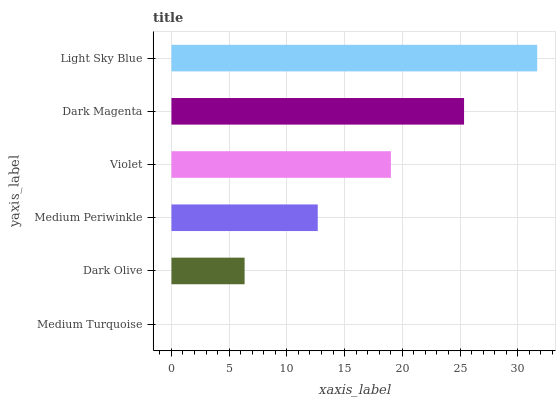Is Medium Turquoise the minimum?
Answer yes or no. Yes. Is Light Sky Blue the maximum?
Answer yes or no. Yes. Is Dark Olive the minimum?
Answer yes or no. No. Is Dark Olive the maximum?
Answer yes or no. No. Is Dark Olive greater than Medium Turquoise?
Answer yes or no. Yes. Is Medium Turquoise less than Dark Olive?
Answer yes or no. Yes. Is Medium Turquoise greater than Dark Olive?
Answer yes or no. No. Is Dark Olive less than Medium Turquoise?
Answer yes or no. No. Is Violet the high median?
Answer yes or no. Yes. Is Medium Periwinkle the low median?
Answer yes or no. Yes. Is Dark Olive the high median?
Answer yes or no. No. Is Light Sky Blue the low median?
Answer yes or no. No. 